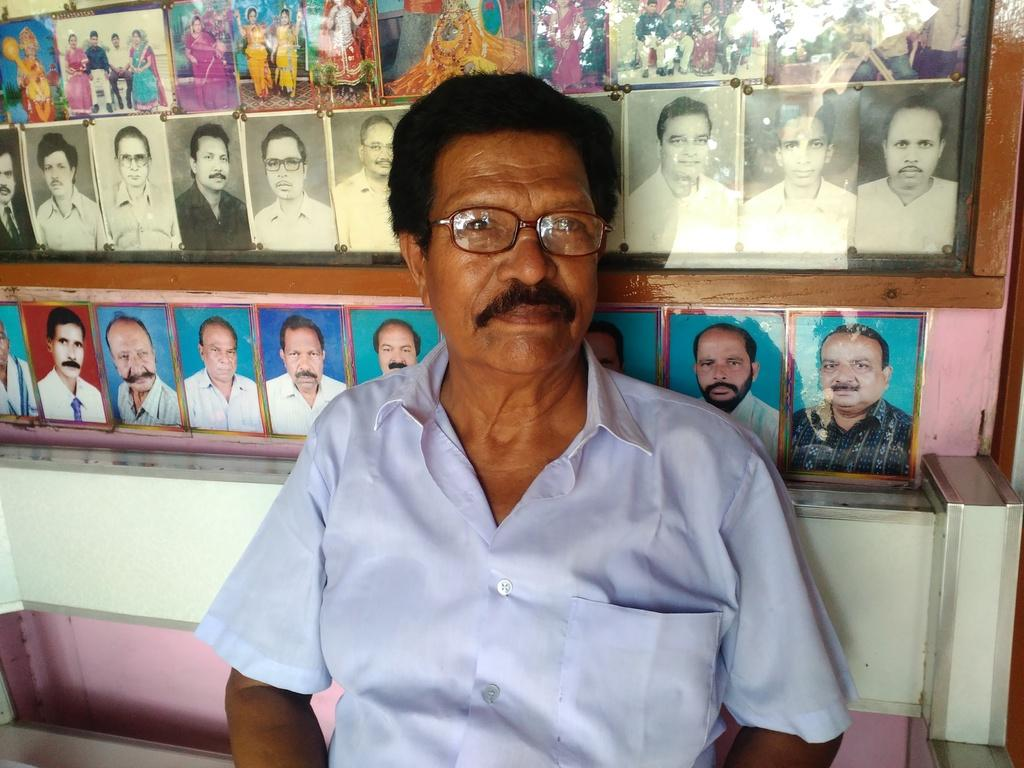Who is present in the image? There is a man in the image. What is the man doing in the image? The man is sitting. What is the man wearing in the image? The man is wearing a blue shirt. What can be seen on the wall in the background of the image? There are photo frames on the wall in the background of the image. What type of silver apparatus is the man using in the image? There is no silver apparatus present in the image. The man is simply sitting and wearing a blue shirt, with photo frames visible on the wall in the background. 